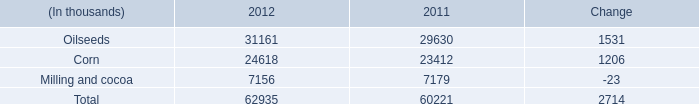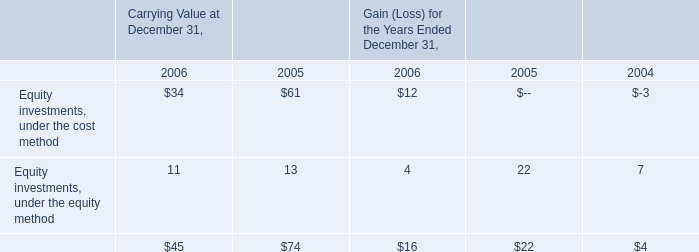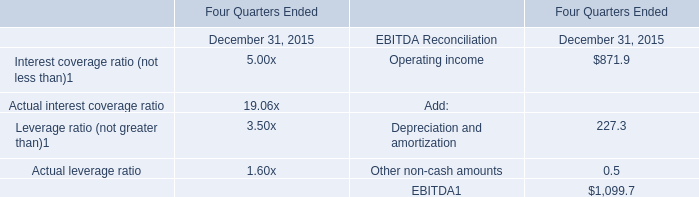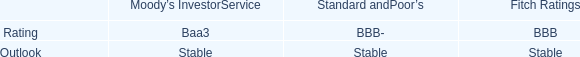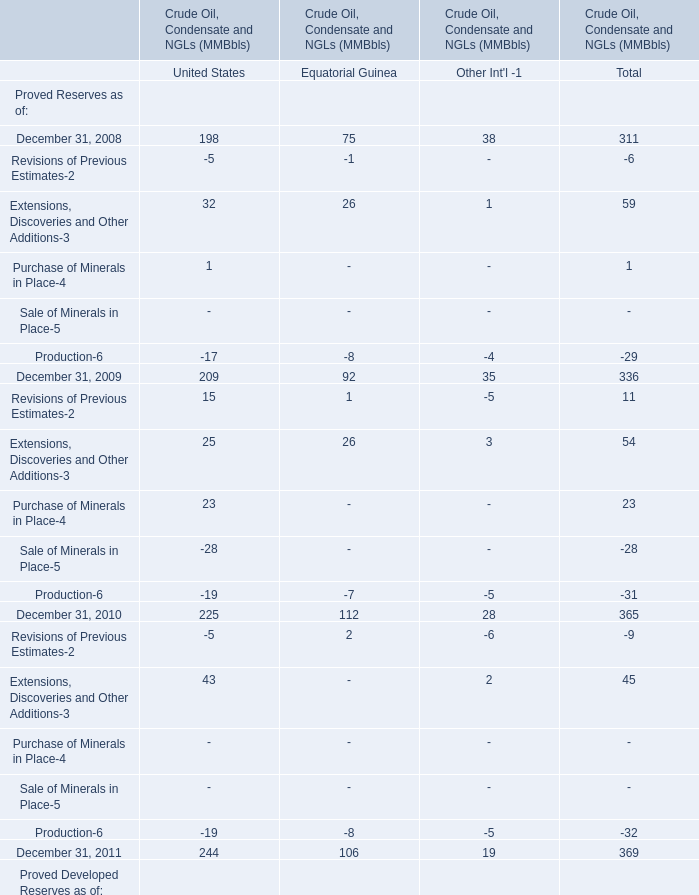What is the difference between Crude Oil, Condensate and NGLs (MMBbls) in United States and Equatorial Guinea 's highest Extensions, Discoveries and Other Additions-3 in 2008? 
Computations: (32 - 26)
Answer: 6.0. 